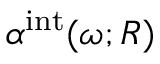<formula> <loc_0><loc_0><loc_500><loc_500>\alpha ^ { i n t } ( \omega ; R )</formula> 